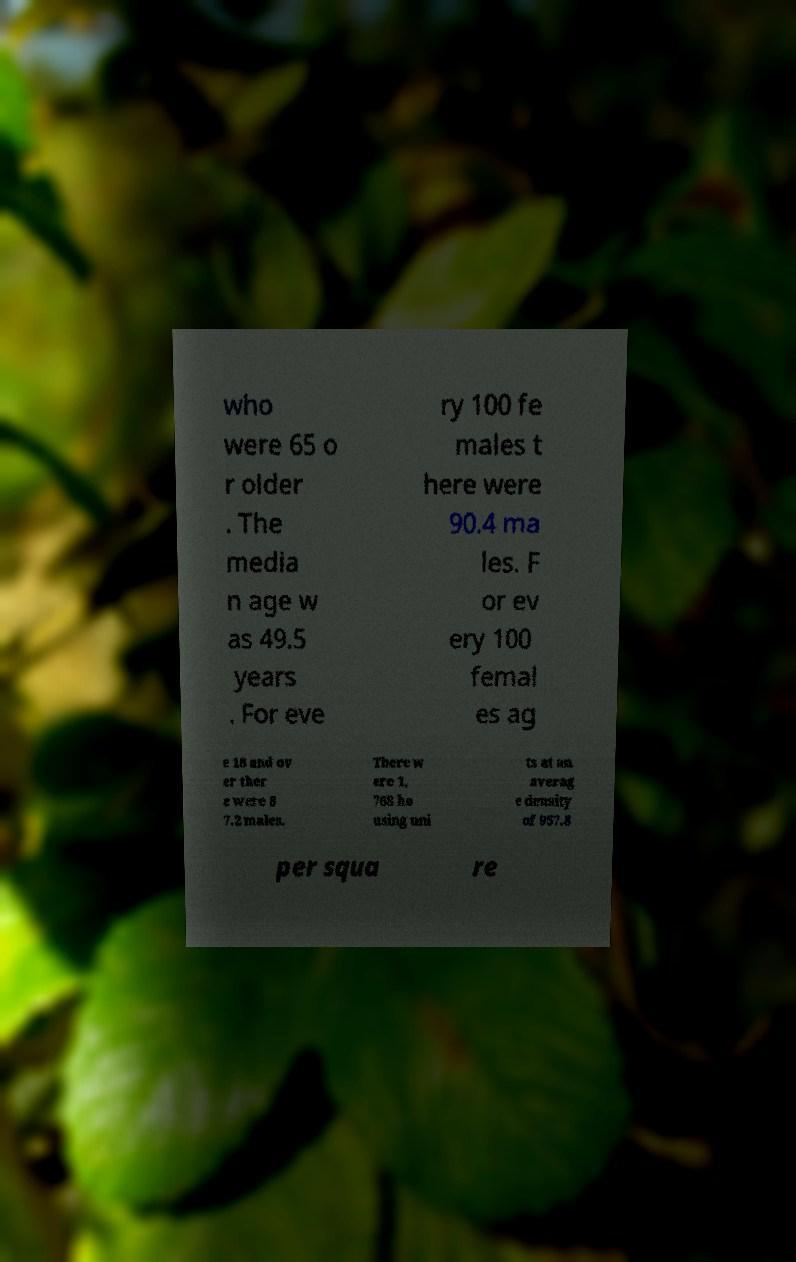Could you assist in decoding the text presented in this image and type it out clearly? who were 65 o r older . The media n age w as 49.5 years . For eve ry 100 fe males t here were 90.4 ma les. F or ev ery 100 femal es ag e 18 and ov er ther e were 8 7.2 males. There w ere 1, 768 ho using uni ts at an averag e density of 957.8 per squa re 